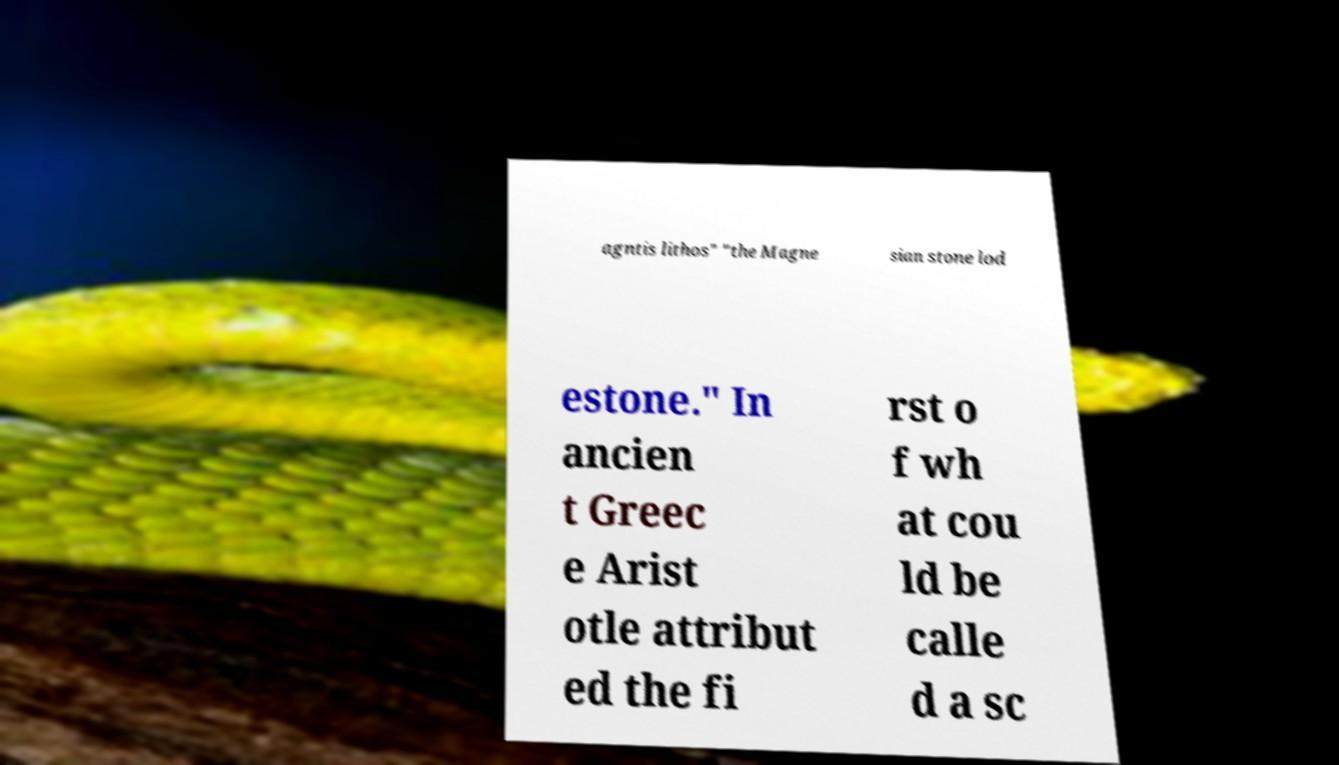Could you extract and type out the text from this image? agntis lithos" "the Magne sian stone lod estone." In ancien t Greec e Arist otle attribut ed the fi rst o f wh at cou ld be calle d a sc 